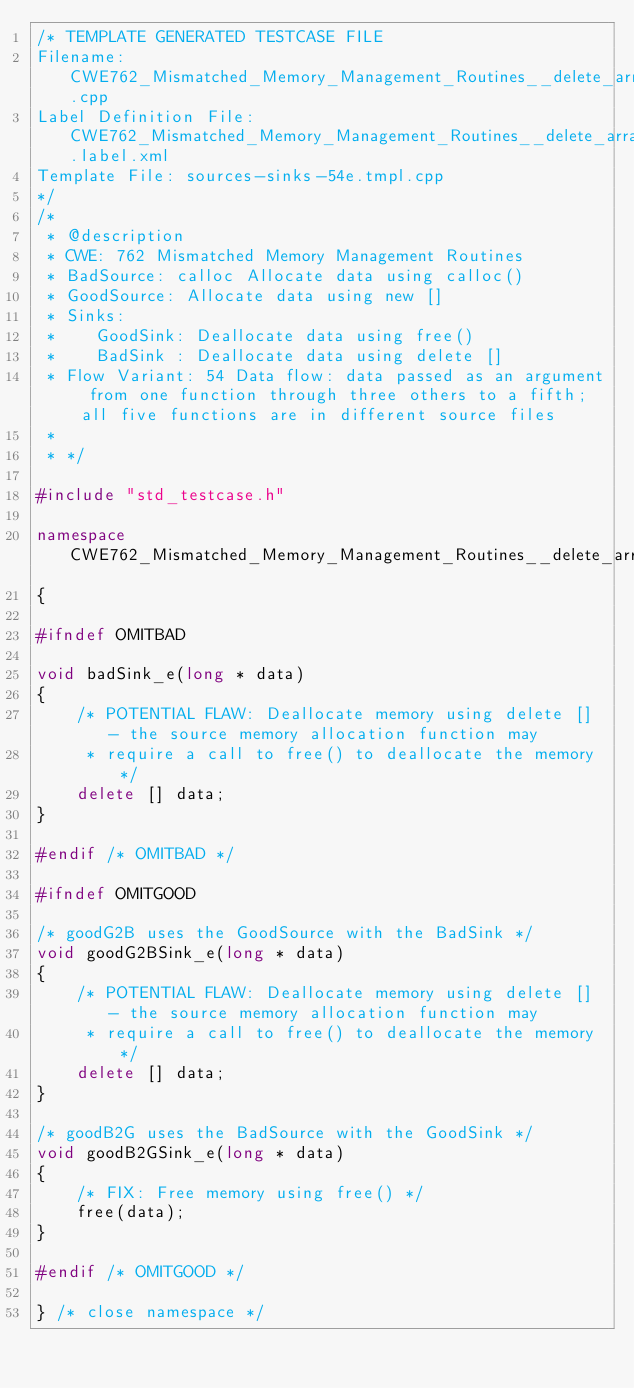<code> <loc_0><loc_0><loc_500><loc_500><_C++_>/* TEMPLATE GENERATED TESTCASE FILE
Filename: CWE762_Mismatched_Memory_Management_Routines__delete_array_long_calloc_54e.cpp
Label Definition File: CWE762_Mismatched_Memory_Management_Routines__delete_array.label.xml
Template File: sources-sinks-54e.tmpl.cpp
*/
/*
 * @description
 * CWE: 762 Mismatched Memory Management Routines
 * BadSource: calloc Allocate data using calloc()
 * GoodSource: Allocate data using new []
 * Sinks:
 *    GoodSink: Deallocate data using free()
 *    BadSink : Deallocate data using delete []
 * Flow Variant: 54 Data flow: data passed as an argument from one function through three others to a fifth; all five functions are in different source files
 *
 * */

#include "std_testcase.h"

namespace CWE762_Mismatched_Memory_Management_Routines__delete_array_long_calloc_54
{

#ifndef OMITBAD

void badSink_e(long * data)
{
    /* POTENTIAL FLAW: Deallocate memory using delete [] - the source memory allocation function may
     * require a call to free() to deallocate the memory */
    delete [] data;
}

#endif /* OMITBAD */

#ifndef OMITGOOD

/* goodG2B uses the GoodSource with the BadSink */
void goodG2BSink_e(long * data)
{
    /* POTENTIAL FLAW: Deallocate memory using delete [] - the source memory allocation function may
     * require a call to free() to deallocate the memory */
    delete [] data;
}

/* goodB2G uses the BadSource with the GoodSink */
void goodB2GSink_e(long * data)
{
    /* FIX: Free memory using free() */
    free(data);
}

#endif /* OMITGOOD */

} /* close namespace */
</code> 